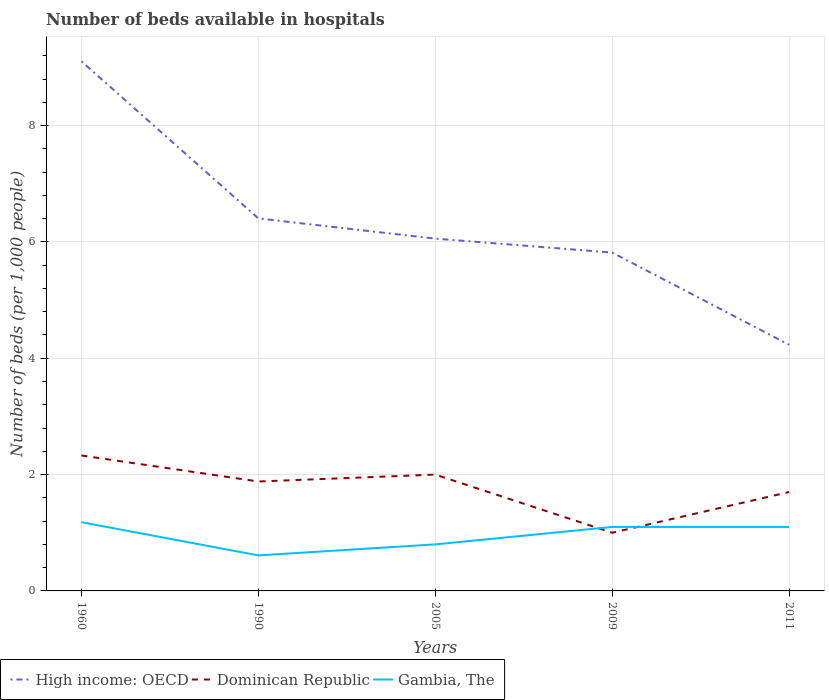Across all years, what is the maximum number of beds in the hospiatls of in Dominican Republic?
Offer a very short reply. 1. In which year was the number of beds in the hospiatls of in Gambia, The maximum?
Provide a succinct answer. 1990. What is the total number of beds in the hospiatls of in Gambia, The in the graph?
Your answer should be compact. 0.38. What is the difference between the highest and the second highest number of beds in the hospiatls of in Gambia, The?
Your answer should be compact. 0.57. What is the difference between two consecutive major ticks on the Y-axis?
Keep it short and to the point. 2. Are the values on the major ticks of Y-axis written in scientific E-notation?
Your answer should be compact. No. Does the graph contain grids?
Your answer should be very brief. Yes. How many legend labels are there?
Keep it short and to the point. 3. What is the title of the graph?
Your answer should be very brief. Number of beds available in hospitals. What is the label or title of the Y-axis?
Offer a very short reply. Number of beds (per 1,0 people). What is the Number of beds (per 1,000 people) in High income: OECD in 1960?
Give a very brief answer. 9.11. What is the Number of beds (per 1,000 people) in Dominican Republic in 1960?
Give a very brief answer. 2.33. What is the Number of beds (per 1,000 people) in Gambia, The in 1960?
Ensure brevity in your answer.  1.18. What is the Number of beds (per 1,000 people) in High income: OECD in 1990?
Your response must be concise. 6.4. What is the Number of beds (per 1,000 people) of Dominican Republic in 1990?
Provide a short and direct response. 1.88. What is the Number of beds (per 1,000 people) of Gambia, The in 1990?
Your answer should be very brief. 0.61. What is the Number of beds (per 1,000 people) in High income: OECD in 2005?
Ensure brevity in your answer.  6.06. What is the Number of beds (per 1,000 people) of Gambia, The in 2005?
Keep it short and to the point. 0.8. What is the Number of beds (per 1,000 people) of High income: OECD in 2009?
Provide a succinct answer. 5.82. What is the Number of beds (per 1,000 people) of Dominican Republic in 2009?
Keep it short and to the point. 1. What is the Number of beds (per 1,000 people) in Gambia, The in 2009?
Your response must be concise. 1.1. What is the Number of beds (per 1,000 people) of High income: OECD in 2011?
Offer a terse response. 4.23. What is the Number of beds (per 1,000 people) of Gambia, The in 2011?
Give a very brief answer. 1.1. Across all years, what is the maximum Number of beds (per 1,000 people) of High income: OECD?
Offer a very short reply. 9.11. Across all years, what is the maximum Number of beds (per 1,000 people) in Dominican Republic?
Ensure brevity in your answer.  2.33. Across all years, what is the maximum Number of beds (per 1,000 people) in Gambia, The?
Your answer should be compact. 1.18. Across all years, what is the minimum Number of beds (per 1,000 people) of High income: OECD?
Provide a succinct answer. 4.23. Across all years, what is the minimum Number of beds (per 1,000 people) in Gambia, The?
Provide a short and direct response. 0.61. What is the total Number of beds (per 1,000 people) in High income: OECD in the graph?
Give a very brief answer. 31.62. What is the total Number of beds (per 1,000 people) in Dominican Republic in the graph?
Give a very brief answer. 8.91. What is the total Number of beds (per 1,000 people) in Gambia, The in the graph?
Provide a succinct answer. 4.79. What is the difference between the Number of beds (per 1,000 people) of High income: OECD in 1960 and that in 1990?
Offer a very short reply. 2.7. What is the difference between the Number of beds (per 1,000 people) in Dominican Republic in 1960 and that in 1990?
Ensure brevity in your answer.  0.45. What is the difference between the Number of beds (per 1,000 people) in Gambia, The in 1960 and that in 1990?
Give a very brief answer. 0.57. What is the difference between the Number of beds (per 1,000 people) of High income: OECD in 1960 and that in 2005?
Provide a short and direct response. 3.05. What is the difference between the Number of beds (per 1,000 people) of Dominican Republic in 1960 and that in 2005?
Your answer should be very brief. 0.33. What is the difference between the Number of beds (per 1,000 people) of Gambia, The in 1960 and that in 2005?
Provide a short and direct response. 0.38. What is the difference between the Number of beds (per 1,000 people) in High income: OECD in 1960 and that in 2009?
Provide a succinct answer. 3.29. What is the difference between the Number of beds (per 1,000 people) in Dominican Republic in 1960 and that in 2009?
Your answer should be compact. 1.33. What is the difference between the Number of beds (per 1,000 people) in Gambia, The in 1960 and that in 2009?
Make the answer very short. 0.08. What is the difference between the Number of beds (per 1,000 people) in High income: OECD in 1960 and that in 2011?
Offer a terse response. 4.87. What is the difference between the Number of beds (per 1,000 people) in Dominican Republic in 1960 and that in 2011?
Provide a succinct answer. 0.63. What is the difference between the Number of beds (per 1,000 people) in Gambia, The in 1960 and that in 2011?
Provide a short and direct response. 0.08. What is the difference between the Number of beds (per 1,000 people) in High income: OECD in 1990 and that in 2005?
Provide a succinct answer. 0.35. What is the difference between the Number of beds (per 1,000 people) in Dominican Republic in 1990 and that in 2005?
Offer a very short reply. -0.12. What is the difference between the Number of beds (per 1,000 people) in Gambia, The in 1990 and that in 2005?
Give a very brief answer. -0.19. What is the difference between the Number of beds (per 1,000 people) of High income: OECD in 1990 and that in 2009?
Offer a terse response. 0.59. What is the difference between the Number of beds (per 1,000 people) of Dominican Republic in 1990 and that in 2009?
Your answer should be very brief. 0.88. What is the difference between the Number of beds (per 1,000 people) in Gambia, The in 1990 and that in 2009?
Offer a terse response. -0.49. What is the difference between the Number of beds (per 1,000 people) in High income: OECD in 1990 and that in 2011?
Keep it short and to the point. 2.17. What is the difference between the Number of beds (per 1,000 people) of Dominican Republic in 1990 and that in 2011?
Ensure brevity in your answer.  0.18. What is the difference between the Number of beds (per 1,000 people) in Gambia, The in 1990 and that in 2011?
Provide a succinct answer. -0.49. What is the difference between the Number of beds (per 1,000 people) in High income: OECD in 2005 and that in 2009?
Your answer should be very brief. 0.24. What is the difference between the Number of beds (per 1,000 people) in Dominican Republic in 2005 and that in 2009?
Your answer should be very brief. 1. What is the difference between the Number of beds (per 1,000 people) of Gambia, The in 2005 and that in 2009?
Provide a succinct answer. -0.3. What is the difference between the Number of beds (per 1,000 people) of High income: OECD in 2005 and that in 2011?
Make the answer very short. 1.82. What is the difference between the Number of beds (per 1,000 people) of High income: OECD in 2009 and that in 2011?
Provide a short and direct response. 1.59. What is the difference between the Number of beds (per 1,000 people) of Dominican Republic in 2009 and that in 2011?
Your response must be concise. -0.7. What is the difference between the Number of beds (per 1,000 people) of High income: OECD in 1960 and the Number of beds (per 1,000 people) of Dominican Republic in 1990?
Offer a terse response. 7.22. What is the difference between the Number of beds (per 1,000 people) of High income: OECD in 1960 and the Number of beds (per 1,000 people) of Gambia, The in 1990?
Your answer should be very brief. 8.49. What is the difference between the Number of beds (per 1,000 people) of Dominican Republic in 1960 and the Number of beds (per 1,000 people) of Gambia, The in 1990?
Provide a short and direct response. 1.72. What is the difference between the Number of beds (per 1,000 people) of High income: OECD in 1960 and the Number of beds (per 1,000 people) of Dominican Republic in 2005?
Your response must be concise. 7.11. What is the difference between the Number of beds (per 1,000 people) of High income: OECD in 1960 and the Number of beds (per 1,000 people) of Gambia, The in 2005?
Ensure brevity in your answer.  8.31. What is the difference between the Number of beds (per 1,000 people) in Dominican Republic in 1960 and the Number of beds (per 1,000 people) in Gambia, The in 2005?
Your answer should be compact. 1.53. What is the difference between the Number of beds (per 1,000 people) in High income: OECD in 1960 and the Number of beds (per 1,000 people) in Dominican Republic in 2009?
Your response must be concise. 8.11. What is the difference between the Number of beds (per 1,000 people) in High income: OECD in 1960 and the Number of beds (per 1,000 people) in Gambia, The in 2009?
Your answer should be very brief. 8.01. What is the difference between the Number of beds (per 1,000 people) of Dominican Republic in 1960 and the Number of beds (per 1,000 people) of Gambia, The in 2009?
Give a very brief answer. 1.23. What is the difference between the Number of beds (per 1,000 people) of High income: OECD in 1960 and the Number of beds (per 1,000 people) of Dominican Republic in 2011?
Your answer should be very brief. 7.41. What is the difference between the Number of beds (per 1,000 people) in High income: OECD in 1960 and the Number of beds (per 1,000 people) in Gambia, The in 2011?
Make the answer very short. 8.01. What is the difference between the Number of beds (per 1,000 people) in Dominican Republic in 1960 and the Number of beds (per 1,000 people) in Gambia, The in 2011?
Give a very brief answer. 1.23. What is the difference between the Number of beds (per 1,000 people) in High income: OECD in 1990 and the Number of beds (per 1,000 people) in Dominican Republic in 2005?
Your answer should be compact. 4.4. What is the difference between the Number of beds (per 1,000 people) of High income: OECD in 1990 and the Number of beds (per 1,000 people) of Gambia, The in 2005?
Your answer should be compact. 5.6. What is the difference between the Number of beds (per 1,000 people) in Dominican Republic in 1990 and the Number of beds (per 1,000 people) in Gambia, The in 2005?
Your response must be concise. 1.08. What is the difference between the Number of beds (per 1,000 people) of High income: OECD in 1990 and the Number of beds (per 1,000 people) of Dominican Republic in 2009?
Make the answer very short. 5.4. What is the difference between the Number of beds (per 1,000 people) of High income: OECD in 1990 and the Number of beds (per 1,000 people) of Gambia, The in 2009?
Give a very brief answer. 5.3. What is the difference between the Number of beds (per 1,000 people) in Dominican Republic in 1990 and the Number of beds (per 1,000 people) in Gambia, The in 2009?
Ensure brevity in your answer.  0.78. What is the difference between the Number of beds (per 1,000 people) of High income: OECD in 1990 and the Number of beds (per 1,000 people) of Dominican Republic in 2011?
Give a very brief answer. 4.7. What is the difference between the Number of beds (per 1,000 people) in High income: OECD in 1990 and the Number of beds (per 1,000 people) in Gambia, The in 2011?
Provide a succinct answer. 5.3. What is the difference between the Number of beds (per 1,000 people) in Dominican Republic in 1990 and the Number of beds (per 1,000 people) in Gambia, The in 2011?
Provide a short and direct response. 0.78. What is the difference between the Number of beds (per 1,000 people) in High income: OECD in 2005 and the Number of beds (per 1,000 people) in Dominican Republic in 2009?
Your response must be concise. 5.06. What is the difference between the Number of beds (per 1,000 people) in High income: OECD in 2005 and the Number of beds (per 1,000 people) in Gambia, The in 2009?
Your answer should be very brief. 4.96. What is the difference between the Number of beds (per 1,000 people) of Dominican Republic in 2005 and the Number of beds (per 1,000 people) of Gambia, The in 2009?
Keep it short and to the point. 0.9. What is the difference between the Number of beds (per 1,000 people) in High income: OECD in 2005 and the Number of beds (per 1,000 people) in Dominican Republic in 2011?
Provide a short and direct response. 4.36. What is the difference between the Number of beds (per 1,000 people) in High income: OECD in 2005 and the Number of beds (per 1,000 people) in Gambia, The in 2011?
Provide a succinct answer. 4.96. What is the difference between the Number of beds (per 1,000 people) of Dominican Republic in 2005 and the Number of beds (per 1,000 people) of Gambia, The in 2011?
Make the answer very short. 0.9. What is the difference between the Number of beds (per 1,000 people) in High income: OECD in 2009 and the Number of beds (per 1,000 people) in Dominican Republic in 2011?
Keep it short and to the point. 4.12. What is the difference between the Number of beds (per 1,000 people) of High income: OECD in 2009 and the Number of beds (per 1,000 people) of Gambia, The in 2011?
Offer a terse response. 4.72. What is the average Number of beds (per 1,000 people) of High income: OECD per year?
Your response must be concise. 6.32. What is the average Number of beds (per 1,000 people) of Dominican Republic per year?
Ensure brevity in your answer.  1.78. What is the average Number of beds (per 1,000 people) of Gambia, The per year?
Ensure brevity in your answer.  0.96. In the year 1960, what is the difference between the Number of beds (per 1,000 people) in High income: OECD and Number of beds (per 1,000 people) in Dominican Republic?
Provide a succinct answer. 6.78. In the year 1960, what is the difference between the Number of beds (per 1,000 people) in High income: OECD and Number of beds (per 1,000 people) in Gambia, The?
Provide a succinct answer. 7.92. In the year 1960, what is the difference between the Number of beds (per 1,000 people) in Dominican Republic and Number of beds (per 1,000 people) in Gambia, The?
Your response must be concise. 1.15. In the year 1990, what is the difference between the Number of beds (per 1,000 people) in High income: OECD and Number of beds (per 1,000 people) in Dominican Republic?
Keep it short and to the point. 4.52. In the year 1990, what is the difference between the Number of beds (per 1,000 people) of High income: OECD and Number of beds (per 1,000 people) of Gambia, The?
Provide a succinct answer. 5.79. In the year 1990, what is the difference between the Number of beds (per 1,000 people) of Dominican Republic and Number of beds (per 1,000 people) of Gambia, The?
Provide a succinct answer. 1.27. In the year 2005, what is the difference between the Number of beds (per 1,000 people) of High income: OECD and Number of beds (per 1,000 people) of Dominican Republic?
Provide a short and direct response. 4.06. In the year 2005, what is the difference between the Number of beds (per 1,000 people) of High income: OECD and Number of beds (per 1,000 people) of Gambia, The?
Give a very brief answer. 5.26. In the year 2005, what is the difference between the Number of beds (per 1,000 people) in Dominican Republic and Number of beds (per 1,000 people) in Gambia, The?
Make the answer very short. 1.2. In the year 2009, what is the difference between the Number of beds (per 1,000 people) of High income: OECD and Number of beds (per 1,000 people) of Dominican Republic?
Make the answer very short. 4.82. In the year 2009, what is the difference between the Number of beds (per 1,000 people) in High income: OECD and Number of beds (per 1,000 people) in Gambia, The?
Give a very brief answer. 4.72. In the year 2009, what is the difference between the Number of beds (per 1,000 people) of Dominican Republic and Number of beds (per 1,000 people) of Gambia, The?
Your answer should be compact. -0.1. In the year 2011, what is the difference between the Number of beds (per 1,000 people) in High income: OECD and Number of beds (per 1,000 people) in Dominican Republic?
Provide a succinct answer. 2.53. In the year 2011, what is the difference between the Number of beds (per 1,000 people) of High income: OECD and Number of beds (per 1,000 people) of Gambia, The?
Ensure brevity in your answer.  3.13. In the year 2011, what is the difference between the Number of beds (per 1,000 people) in Dominican Republic and Number of beds (per 1,000 people) in Gambia, The?
Offer a very short reply. 0.6. What is the ratio of the Number of beds (per 1,000 people) of High income: OECD in 1960 to that in 1990?
Offer a very short reply. 1.42. What is the ratio of the Number of beds (per 1,000 people) in Dominican Republic in 1960 to that in 1990?
Your answer should be very brief. 1.24. What is the ratio of the Number of beds (per 1,000 people) in Gambia, The in 1960 to that in 1990?
Your answer should be compact. 1.93. What is the ratio of the Number of beds (per 1,000 people) of High income: OECD in 1960 to that in 2005?
Keep it short and to the point. 1.5. What is the ratio of the Number of beds (per 1,000 people) of Dominican Republic in 1960 to that in 2005?
Make the answer very short. 1.16. What is the ratio of the Number of beds (per 1,000 people) in Gambia, The in 1960 to that in 2005?
Offer a very short reply. 1.48. What is the ratio of the Number of beds (per 1,000 people) of High income: OECD in 1960 to that in 2009?
Give a very brief answer. 1.57. What is the ratio of the Number of beds (per 1,000 people) in Dominican Republic in 1960 to that in 2009?
Your answer should be compact. 2.33. What is the ratio of the Number of beds (per 1,000 people) in Gambia, The in 1960 to that in 2009?
Your answer should be very brief. 1.07. What is the ratio of the Number of beds (per 1,000 people) in High income: OECD in 1960 to that in 2011?
Offer a very short reply. 2.15. What is the ratio of the Number of beds (per 1,000 people) of Dominican Republic in 1960 to that in 2011?
Make the answer very short. 1.37. What is the ratio of the Number of beds (per 1,000 people) in Gambia, The in 1960 to that in 2011?
Keep it short and to the point. 1.07. What is the ratio of the Number of beds (per 1,000 people) in High income: OECD in 1990 to that in 2005?
Your response must be concise. 1.06. What is the ratio of the Number of beds (per 1,000 people) of Dominican Republic in 1990 to that in 2005?
Give a very brief answer. 0.94. What is the ratio of the Number of beds (per 1,000 people) in Gambia, The in 1990 to that in 2005?
Ensure brevity in your answer.  0.76. What is the ratio of the Number of beds (per 1,000 people) of High income: OECD in 1990 to that in 2009?
Give a very brief answer. 1.1. What is the ratio of the Number of beds (per 1,000 people) of Dominican Republic in 1990 to that in 2009?
Keep it short and to the point. 1.88. What is the ratio of the Number of beds (per 1,000 people) in Gambia, The in 1990 to that in 2009?
Your answer should be very brief. 0.56. What is the ratio of the Number of beds (per 1,000 people) in High income: OECD in 1990 to that in 2011?
Make the answer very short. 1.51. What is the ratio of the Number of beds (per 1,000 people) of Dominican Republic in 1990 to that in 2011?
Your answer should be compact. 1.11. What is the ratio of the Number of beds (per 1,000 people) in Gambia, The in 1990 to that in 2011?
Make the answer very short. 0.56. What is the ratio of the Number of beds (per 1,000 people) in High income: OECD in 2005 to that in 2009?
Your answer should be very brief. 1.04. What is the ratio of the Number of beds (per 1,000 people) of Dominican Republic in 2005 to that in 2009?
Your response must be concise. 2. What is the ratio of the Number of beds (per 1,000 people) of Gambia, The in 2005 to that in 2009?
Your answer should be compact. 0.73. What is the ratio of the Number of beds (per 1,000 people) in High income: OECD in 2005 to that in 2011?
Give a very brief answer. 1.43. What is the ratio of the Number of beds (per 1,000 people) of Dominican Republic in 2005 to that in 2011?
Provide a succinct answer. 1.18. What is the ratio of the Number of beds (per 1,000 people) of Gambia, The in 2005 to that in 2011?
Your answer should be compact. 0.73. What is the ratio of the Number of beds (per 1,000 people) of High income: OECD in 2009 to that in 2011?
Ensure brevity in your answer.  1.37. What is the ratio of the Number of beds (per 1,000 people) of Dominican Republic in 2009 to that in 2011?
Offer a terse response. 0.59. What is the difference between the highest and the second highest Number of beds (per 1,000 people) of High income: OECD?
Your answer should be compact. 2.7. What is the difference between the highest and the second highest Number of beds (per 1,000 people) in Dominican Republic?
Give a very brief answer. 0.33. What is the difference between the highest and the second highest Number of beds (per 1,000 people) of Gambia, The?
Offer a terse response. 0.08. What is the difference between the highest and the lowest Number of beds (per 1,000 people) in High income: OECD?
Provide a short and direct response. 4.87. What is the difference between the highest and the lowest Number of beds (per 1,000 people) of Dominican Republic?
Ensure brevity in your answer.  1.33. What is the difference between the highest and the lowest Number of beds (per 1,000 people) in Gambia, The?
Your response must be concise. 0.57. 